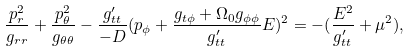<formula> <loc_0><loc_0><loc_500><loc_500>\frac { p _ { r } ^ { 2 } } { g _ { r r } } + \frac { p _ { \theta } ^ { 2 } } { g _ { \theta \theta } } - \frac { g _ { t t } ^ { \prime } } { - D } ( p _ { \phi } + \frac { g _ { t \phi } + \Omega _ { 0 } g _ { \phi \phi } } { g _ { t t } ^ { \prime } } E ) ^ { 2 } = - ( \frac { E ^ { 2 } } { g _ { t t } ^ { \prime } } + \mu ^ { 2 } ) ,</formula> 